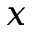<formula> <loc_0><loc_0><loc_500><loc_500>x</formula> 